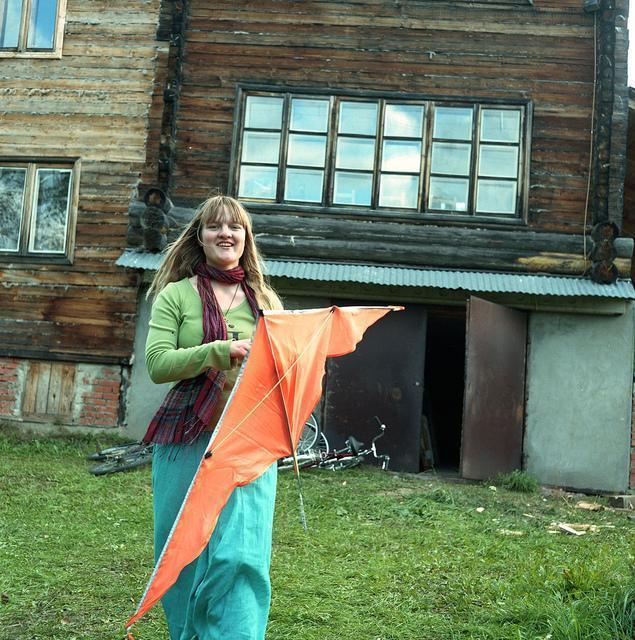How many people are on the ski lift?
Give a very brief answer. 0. 